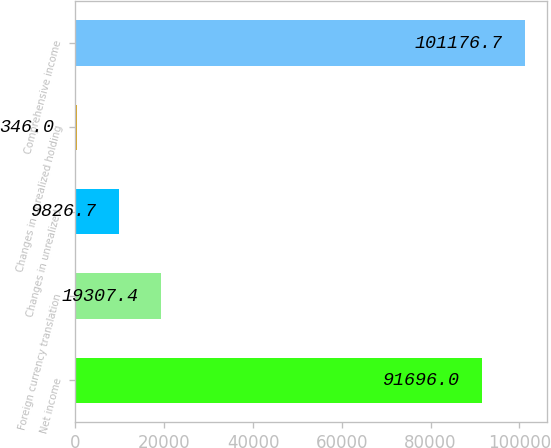Convert chart to OTSL. <chart><loc_0><loc_0><loc_500><loc_500><bar_chart><fcel>Net income<fcel>Foreign currency translation<fcel>Changes in unrealized<fcel>Changes in unrealized holding<fcel>Comprehensive income<nl><fcel>91696<fcel>19307.4<fcel>9826.7<fcel>346<fcel>101177<nl></chart> 